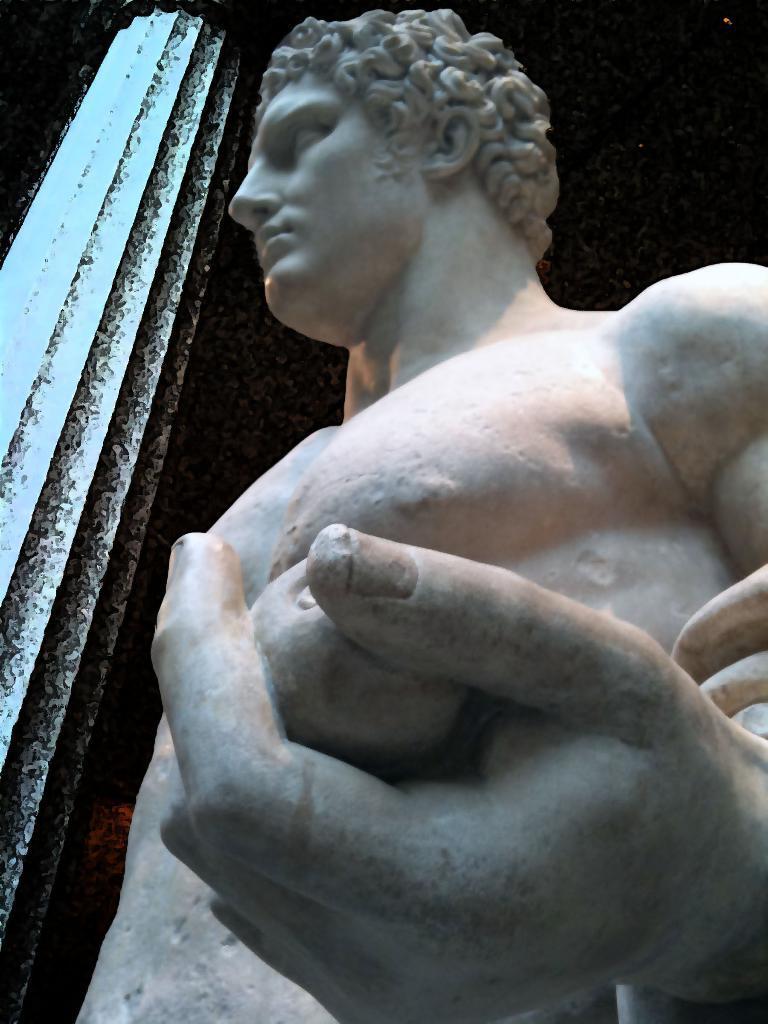How would you summarize this image in a sentence or two? In this image we can see a sculpture and a pillar, also we can see the background is dark. 